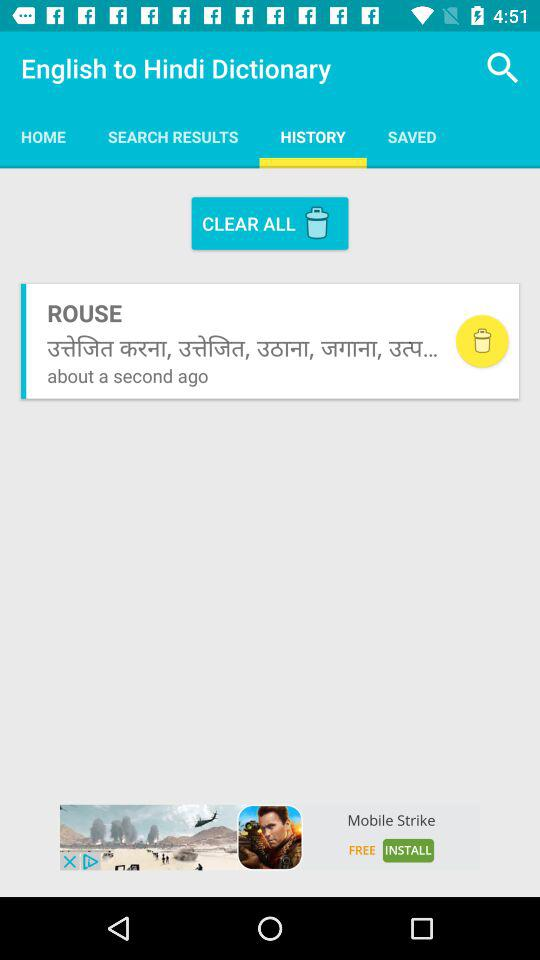Which tab am I on? You are on the "HISTORY" tab. 